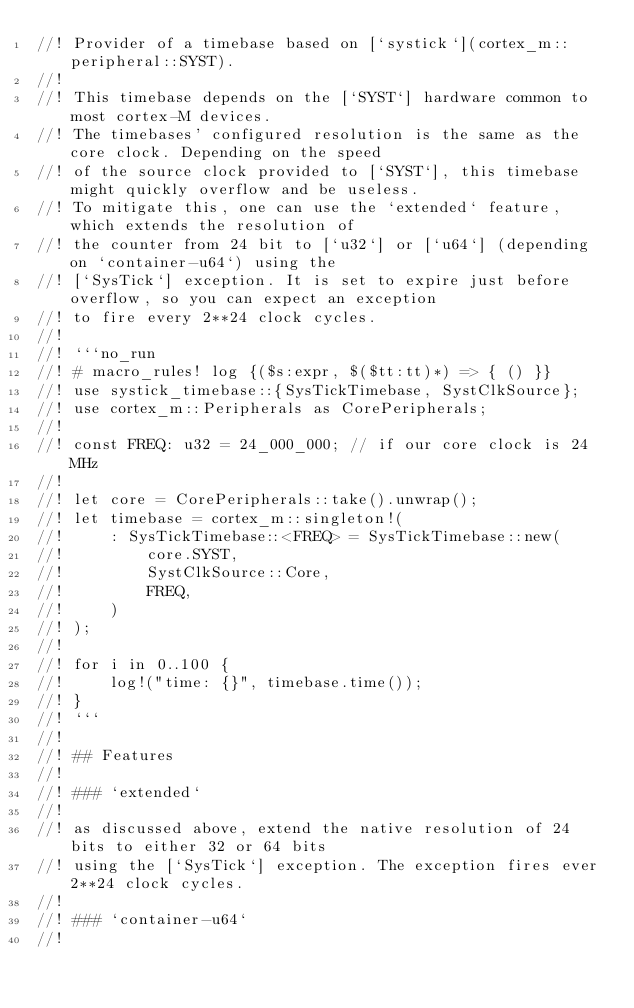<code> <loc_0><loc_0><loc_500><loc_500><_Rust_>//! Provider of a timebase based on [`systick`](cortex_m::peripheral::SYST).
//!
//! This timebase depends on the [`SYST`] hardware common to most cortex-M devices.
//! The timebases' configured resolution is the same as the core clock. Depending on the speed
//! of the source clock provided to [`SYST`], this timebase might quickly overflow and be useless.
//! To mitigate this, one can use the `extended` feature, which extends the resolution of
//! the counter from 24 bit to [`u32`] or [`u64`] (depending on `container-u64`) using the
//! [`SysTick`] exception. It is set to expire just before overflow, so you can expect an exception
//! to fire every 2**24 clock cycles.
//!
//! ```no_run
//! # macro_rules! log {($s:expr, $($tt:tt)*) => { () }}
//! use systick_timebase::{SysTickTimebase, SystClkSource};
//! use cortex_m::Peripherals as CorePeripherals;
//!
//! const FREQ: u32 = 24_000_000; // if our core clock is 24 MHz
//!
//! let core = CorePeripherals::take().unwrap();
//! let timebase = cortex_m::singleton!(
//!     : SysTickTimebase::<FREQ> = SysTickTimebase::new(
//!         core.SYST,
//!         SystClkSource::Core,
//!         FREQ,
//!     )
//! );
//!
//! for i in 0..100 {
//!     log!("time: {}", timebase.time());
//! }
//! ```
//!
//! ## Features
//!
//! ### `extended`
//!
//! as discussed above, extend the native resolution of 24 bits to either 32 or 64 bits
//! using the [`SysTick`] exception. The exception fires ever 2**24 clock cycles.
//!
//! ### `container-u64`
//!</code> 